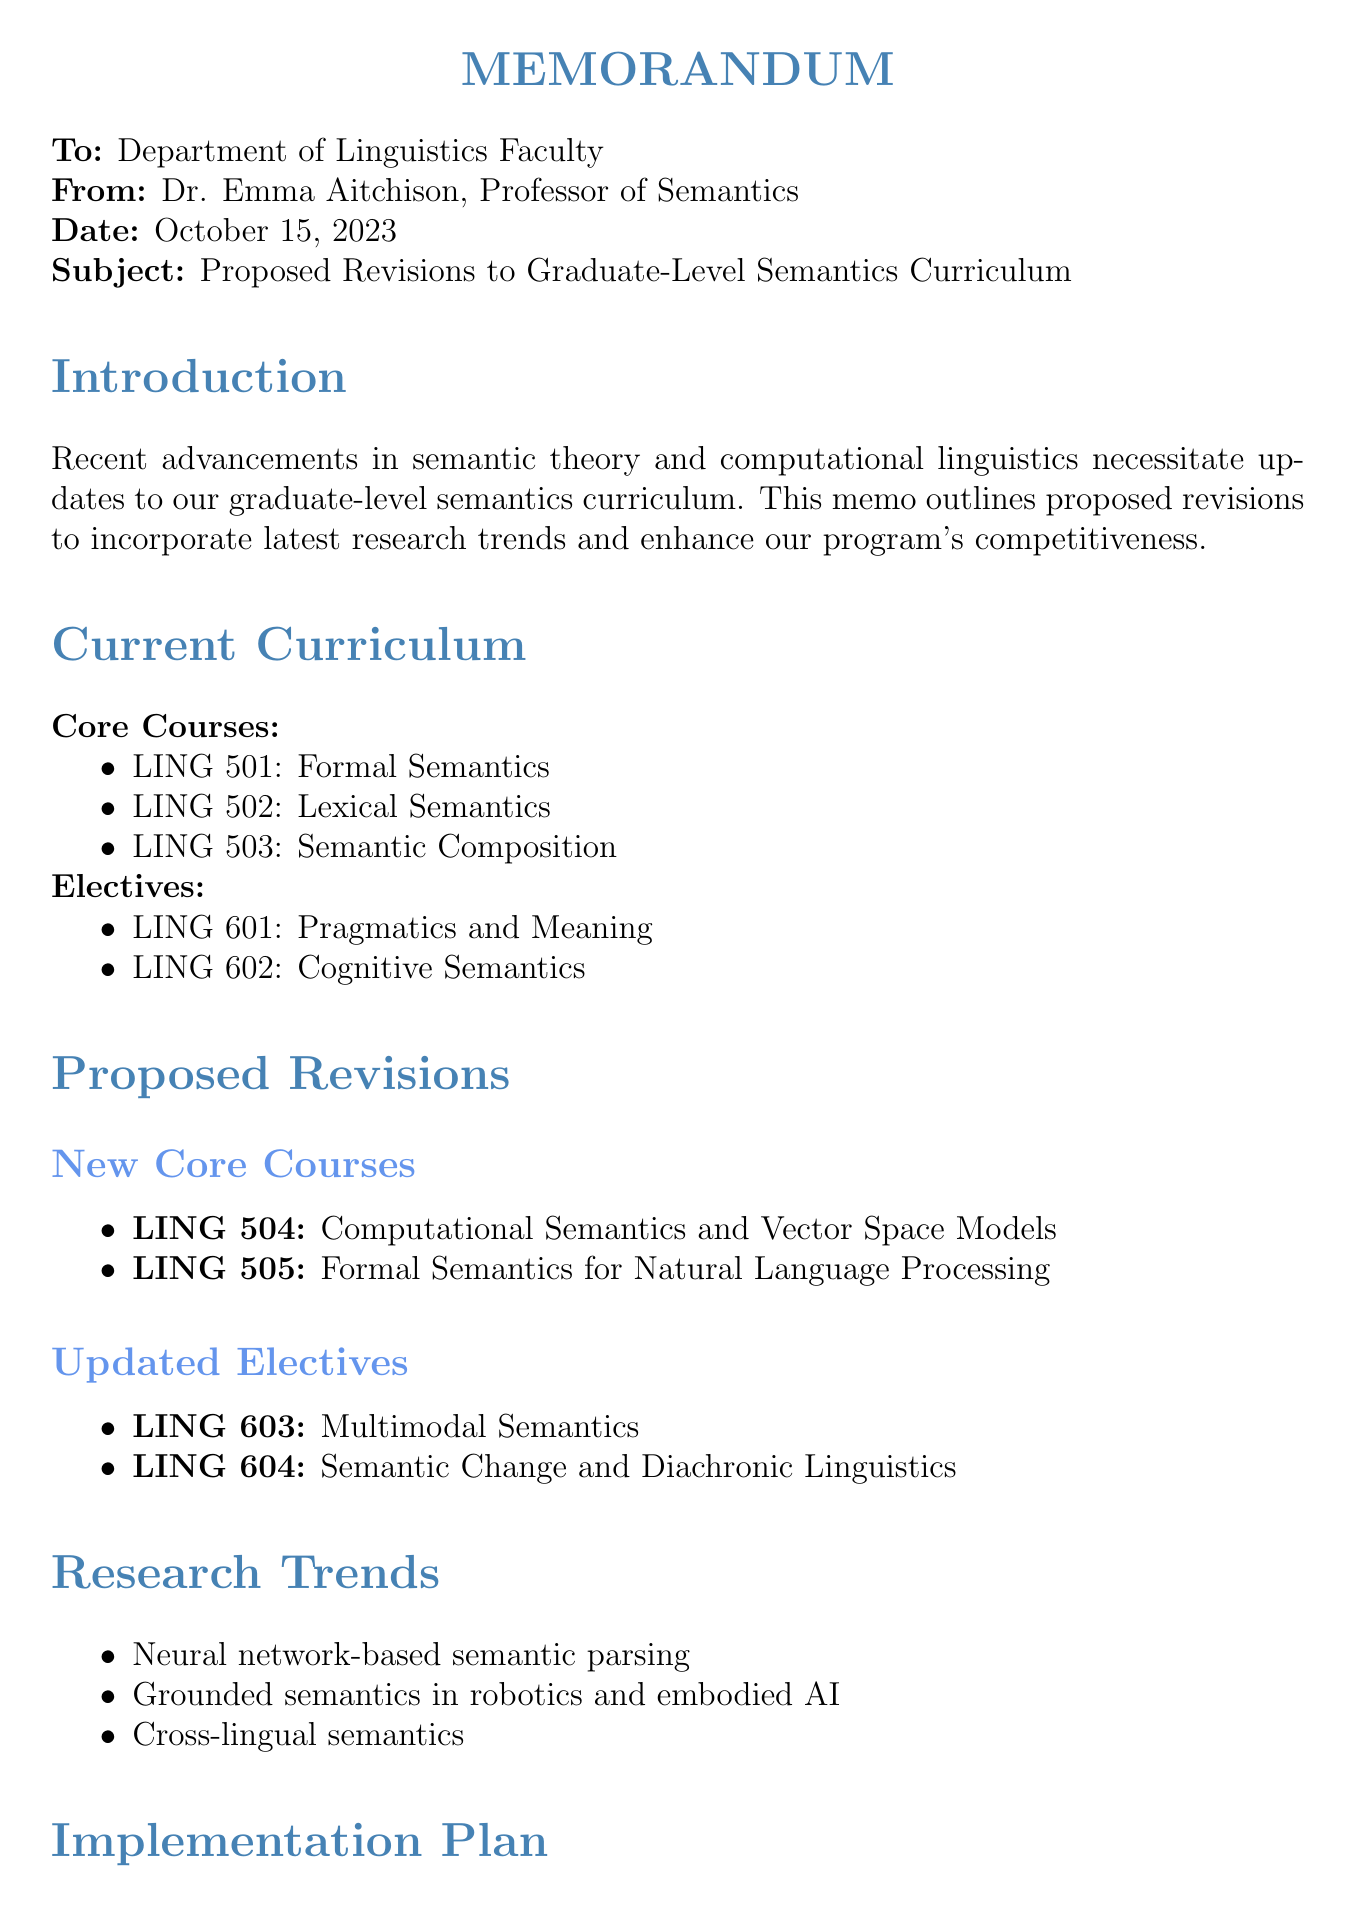What is the date of the memo? The date of the memo is stated directly in the header of the document.
Answer: October 15, 2023 Who is the sender of the memo? The sender of the memo is listed in the header, identifying the author.
Answer: Dr. Emma Aitchison What is the subject of the memo? The subject is specifically mentioned as the main topic of the memo in the header section.
Answer: Proposed Revisions to Graduate-Level Semantics Curriculum What are the proposed new core courses? The new core courses are listed under proposed revisions in the document.
Answer: LING 504, LING 505 What is the rationale for LING 504? The rationale for this course is explained alongside its title in the proposed revisions section.
Answer: Incorporates recent developments in distributional semantics and word embeddings How many resources are needed for the implementation plan? The resources needed are directly outlined in the implementation plan section.
Answer: Three What are the expected outcomes listed in the memo? The expected outcomes are listed in a specific section that summarizes the benefits expected from the proposed revisions.
Answer: Enhanced student preparedness for industry and academic careers in NLP and AI, increased research output in cutting-edge semantic theory, improved competitiveness in graduate student recruitment What is one of the research trends mentioned? The trends are explicitly listed under a dedicated section in the memo.
Answer: Neural network-based semantic parsing When will the faculty vote take place? This information is provided in the implementation plan under the timeline section.
Answer: December 2023 